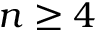<formula> <loc_0><loc_0><loc_500><loc_500>n \geq 4</formula> 